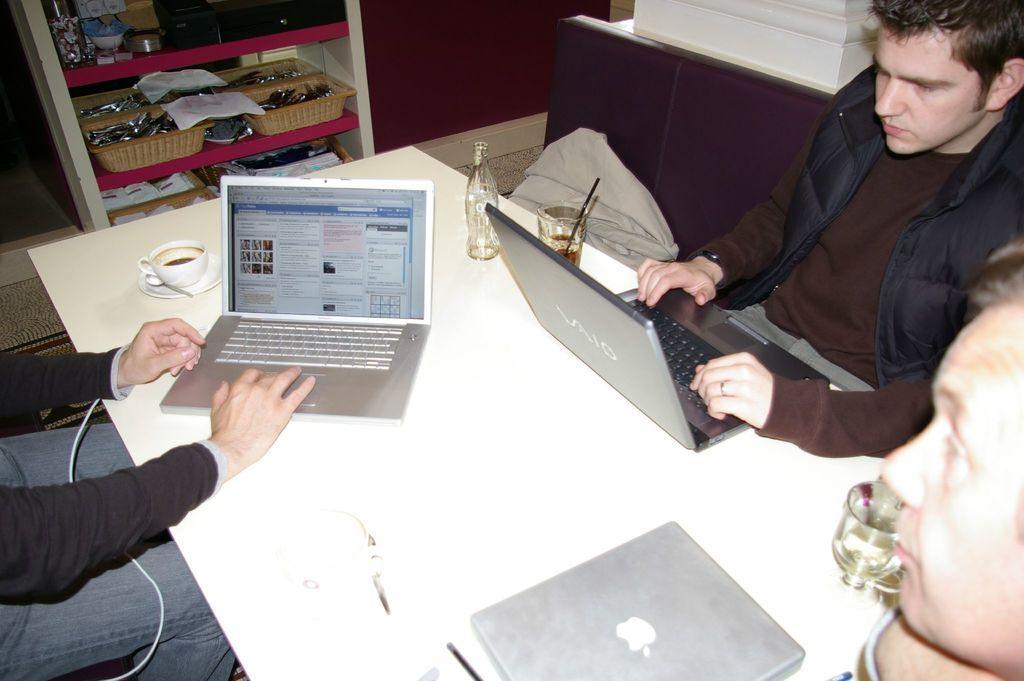How would you summarize this image in a sentence or two? In the background we can see the objects and baskets in the racks. In this picture we can see the people near to a table. On the table we can see the laptops, cup, saucer, spoon, bottle, glasses, drink in the glass with a black straw and few objects. In this picture we can see the floor carpet on the floor and a pillar is visible on the right side of the picture. 